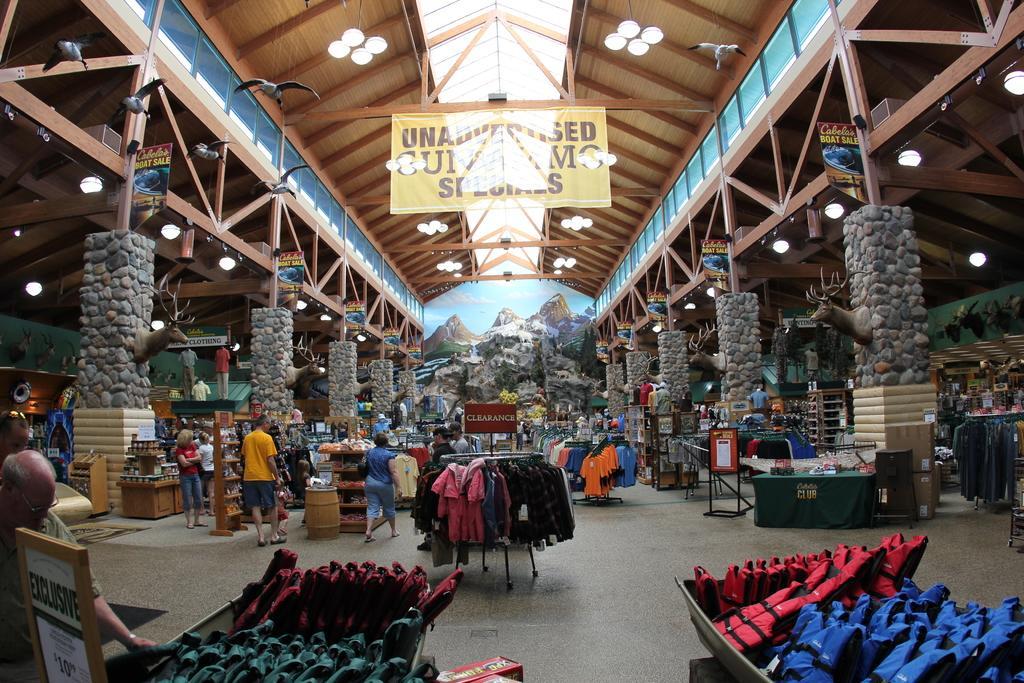Could you give a brief overview of what you see in this image? In this image we can see the people. We can also see the closet, clothes, text boards, banner with the text and also the stone pillars with the depiction of animals. We can also see some tables with some objects. In the background we can see the frame. At the top we can see the lights and also the roof for shelter. 